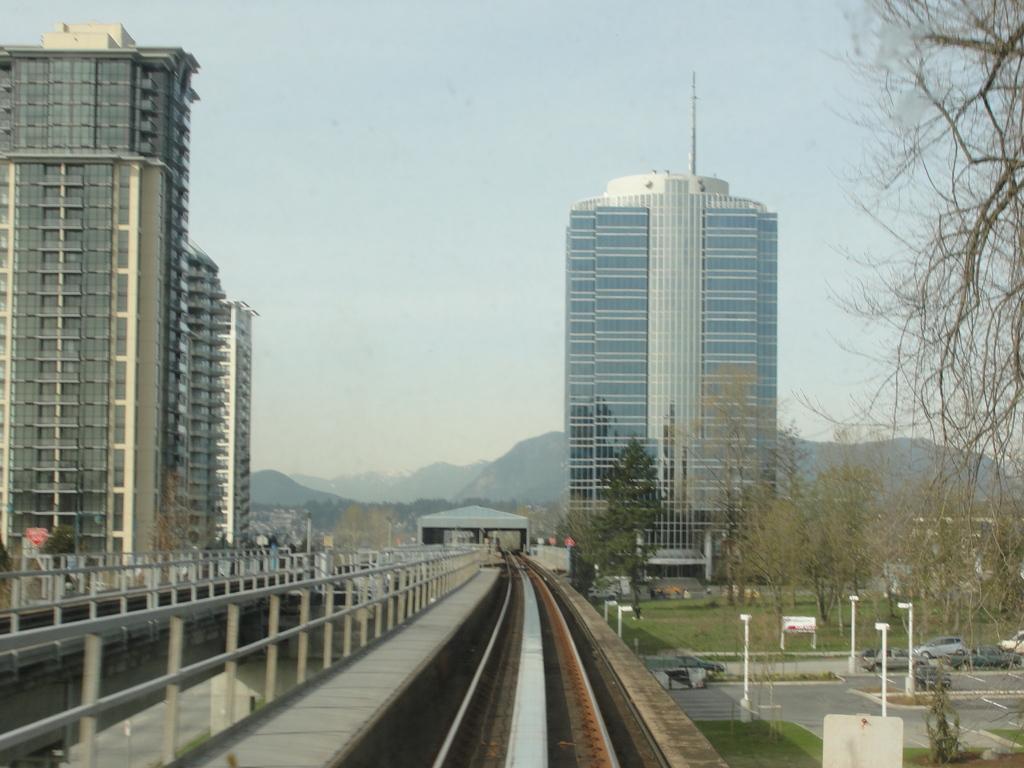Please provide a concise description of this image. This image is clicked on a railway bridge. Beside the track there is a railing. In the background there are buildings and trees. Behind the buildings there are mountains. At the top there is the sky. In the bottom right there is a road. There are vehicles moving on the road. Beside the road there are street light poles. There is grass on the ground. 